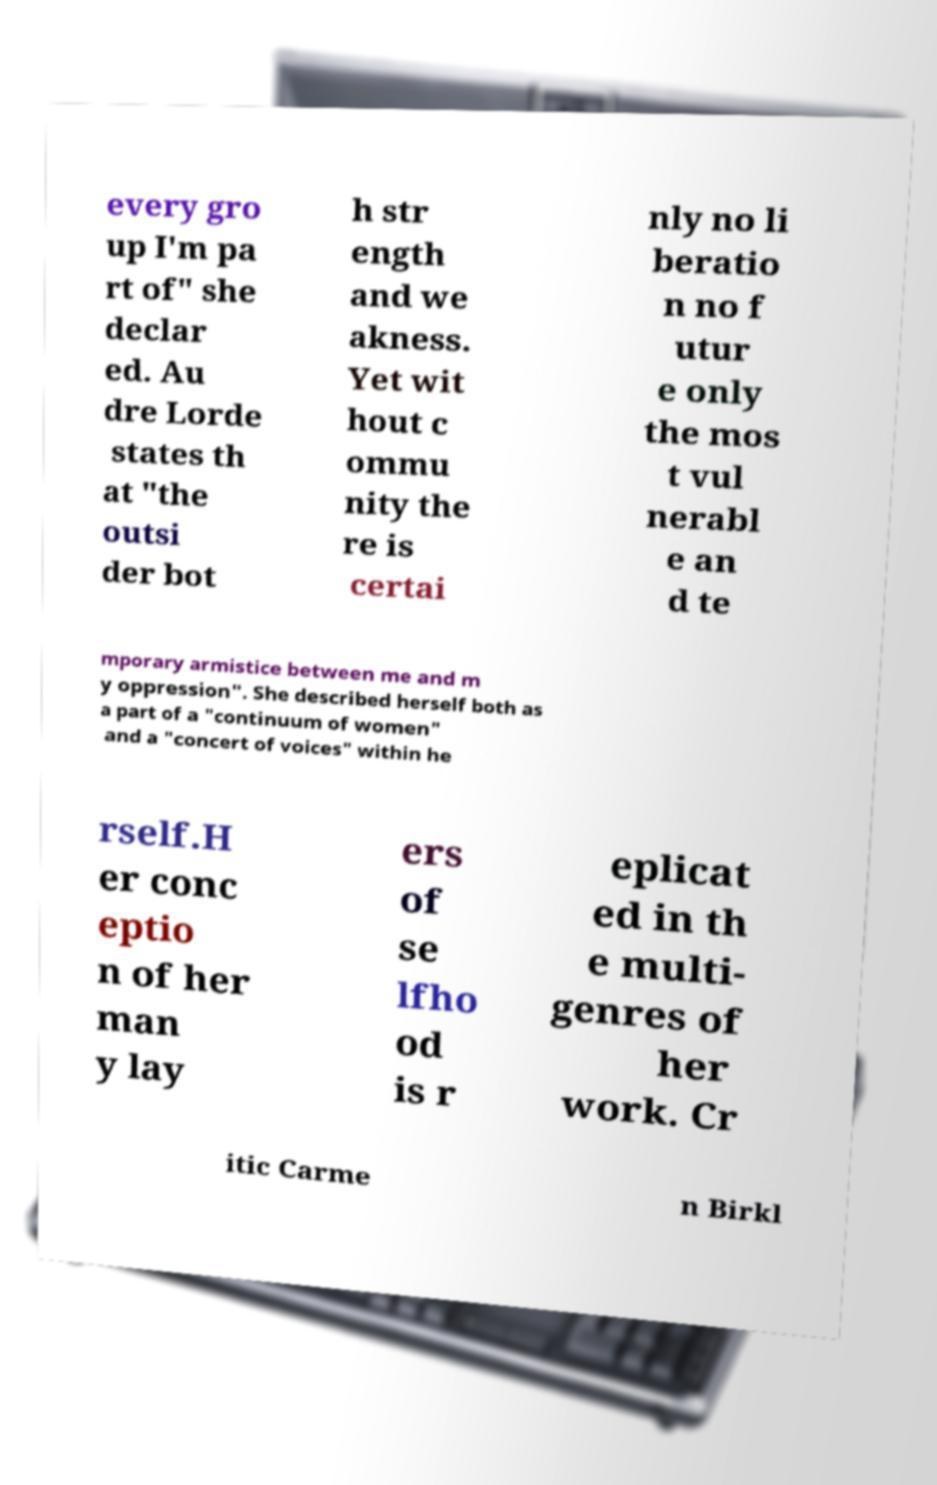Can you accurately transcribe the text from the provided image for me? every gro up I'm pa rt of" she declar ed. Au dre Lorde states th at "the outsi der bot h str ength and we akness. Yet wit hout c ommu nity the re is certai nly no li beratio n no f utur e only the mos t vul nerabl e an d te mporary armistice between me and m y oppression". She described herself both as a part of a "continuum of women" and a "concert of voices" within he rself.H er conc eptio n of her man y lay ers of se lfho od is r eplicat ed in th e multi- genres of her work. Cr itic Carme n Birkl 